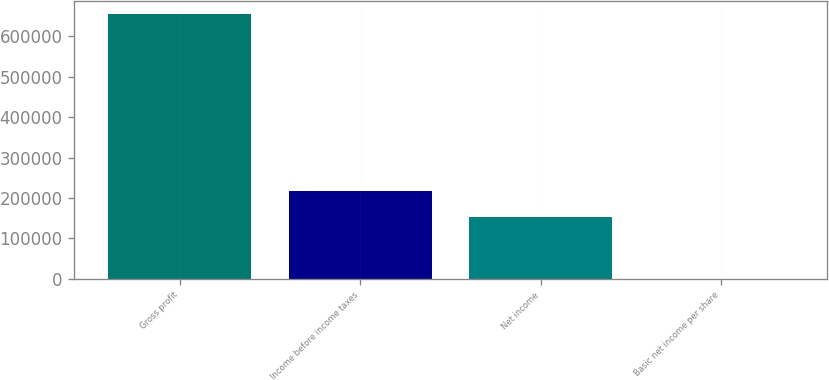<chart> <loc_0><loc_0><loc_500><loc_500><bar_chart><fcel>Gross profit<fcel>Income before income taxes<fcel>Net income<fcel>Basic net income per share<nl><fcel>654363<fcel>217941<fcel>152505<fcel>0.26<nl></chart> 